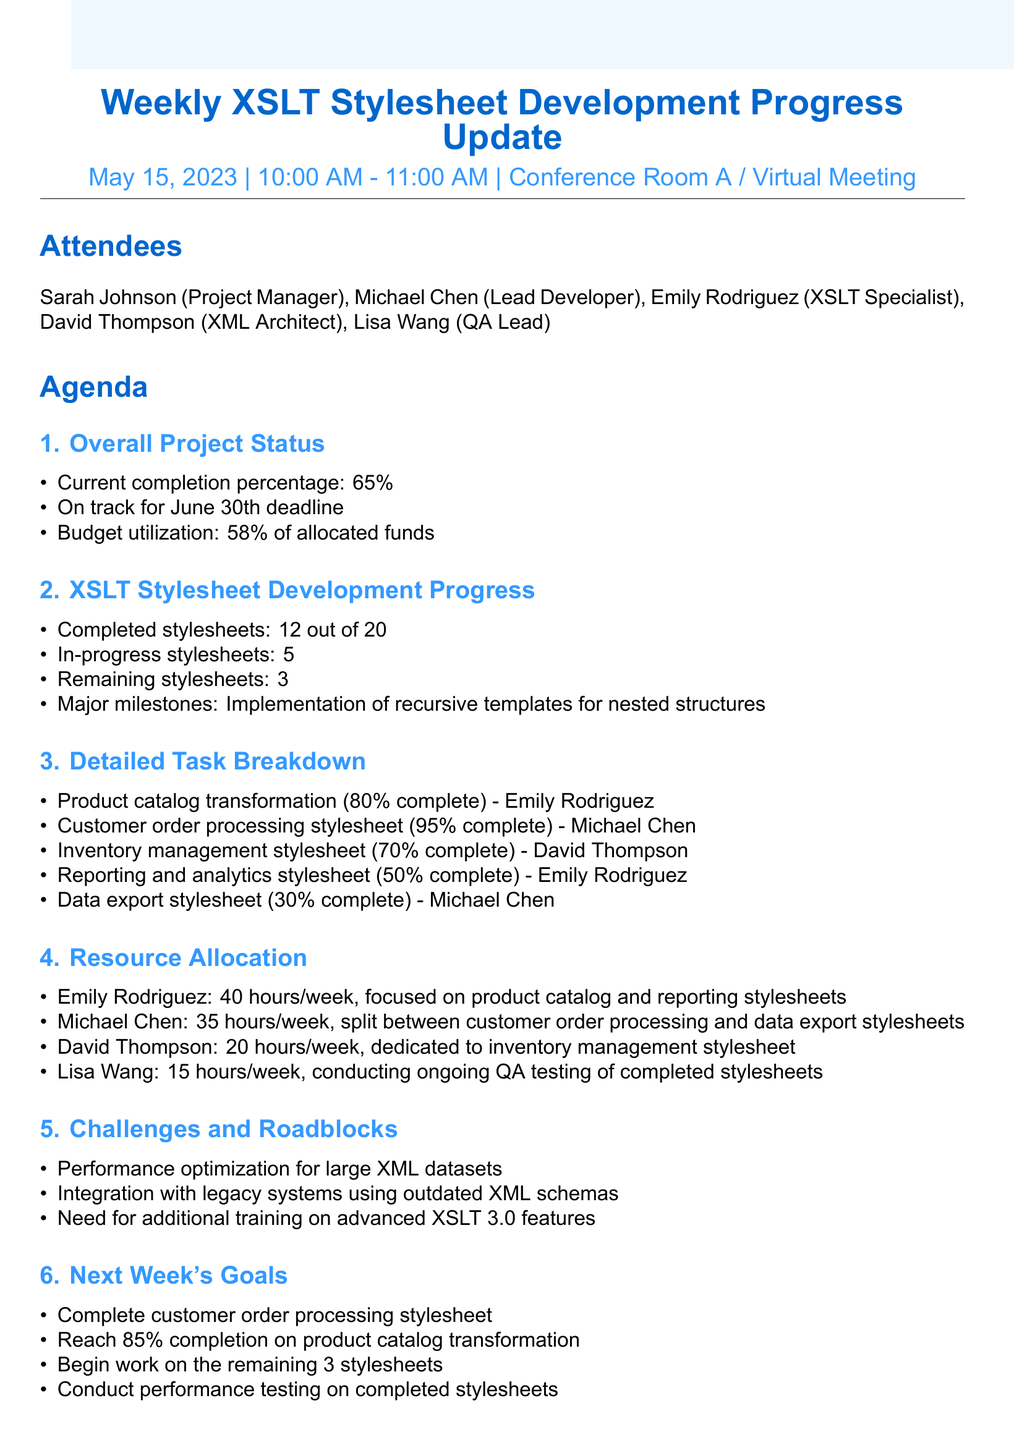What is the date of the meeting? The date of the meeting is specified in the document.
Answer: May 15, 2023 Who leads the customer order processing stylesheet? The document lists the team members responsible for different stylesheets.
Answer: Michael Chen What is the completion percentage of the product catalog transformation? The document provides the completion status of various tasks.
Answer: 80% How many stylesheets have been completed? The total number of completed stylesheets is clearly stated in the document.
Answer: 12 What is the hourly allocation for Lisa Wang? The document specifies the weekly hours dedicated by each team member.
Answer: 15 hours/week What is one of the challenges faced in the project? The document outlines various challenges encountered during development.
Answer: Performance optimization for large XML datasets What percentage of the budget has been utilized? The document indicates the budget status as part of the overall project update.
Answer: 58% of allocated funds What is the next goal for the product catalog transformation? The document specifies the goals set for the upcoming week.
Answer: Reach 85% completion Who is responsible for leading the XSLT 3.0 training session? The action items in the document detail responsibilities for various tasks.
Answer: Michael Chen How many remaining stylesheets are there to be worked on? The document breaks down the count of remaining stylesheets.
Answer: 3 